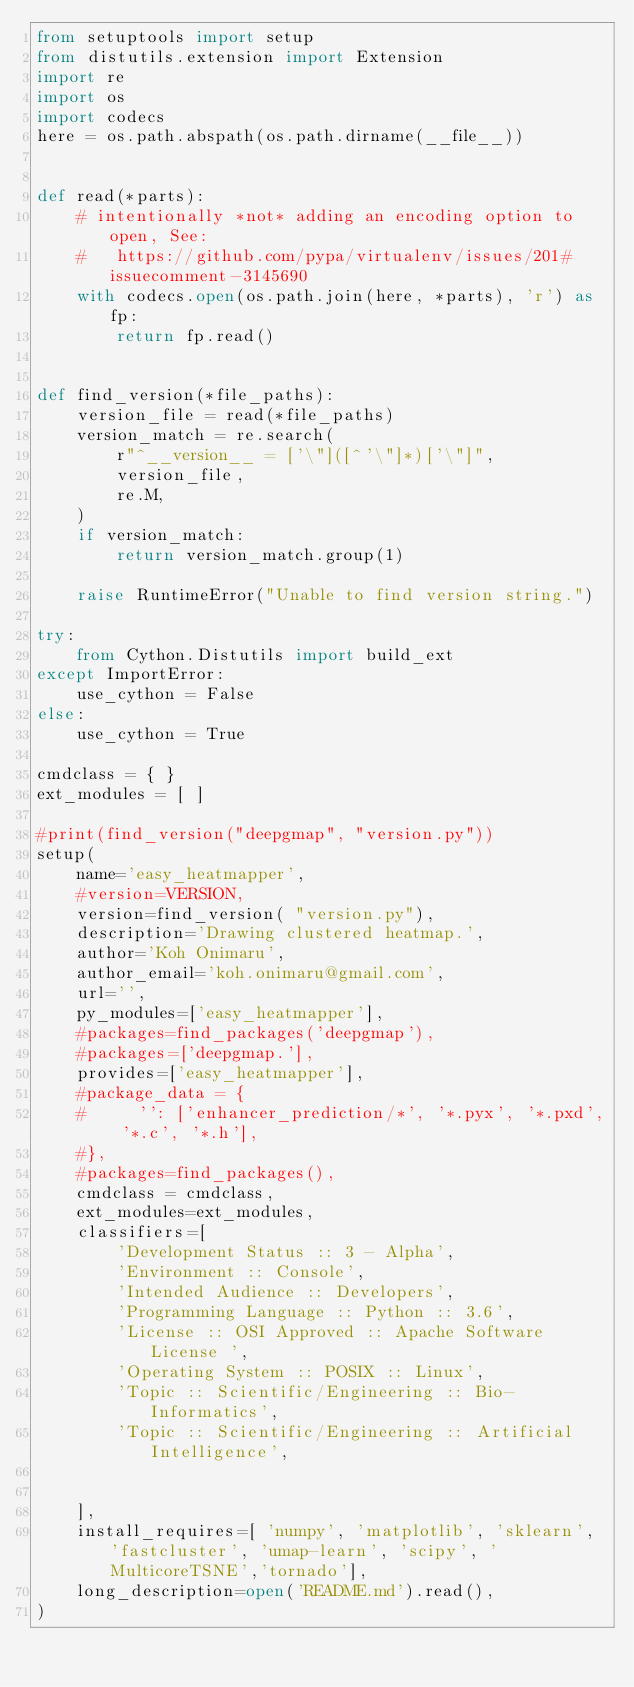Convert code to text. <code><loc_0><loc_0><loc_500><loc_500><_Python_>from setuptools import setup
from distutils.extension import Extension
import re
import os
import codecs
here = os.path.abspath(os.path.dirname(__file__))


def read(*parts):
    # intentionally *not* adding an encoding option to open, See:
    #   https://github.com/pypa/virtualenv/issues/201#issuecomment-3145690
    with codecs.open(os.path.join(here, *parts), 'r') as fp:
        return fp.read()


def find_version(*file_paths):
    version_file = read(*file_paths)
    version_match = re.search(
        r"^__version__ = ['\"]([^'\"]*)['\"]",
        version_file,
        re.M,
    )
    if version_match:
        return version_match.group(1)

    raise RuntimeError("Unable to find version string.")

try:
    from Cython.Distutils import build_ext
except ImportError:
    use_cython = False
else:
    use_cython = True

cmdclass = { }
ext_modules = [ ]

#print(find_version("deepgmap", "version.py"))
setup(
    name='easy_heatmapper',
    #version=VERSION,
    version=find_version( "version.py"),
    description='Drawing clustered heatmap.',
    author='Koh Onimaru',
    author_email='koh.onimaru@gmail.com',
    url='',
    py_modules=['easy_heatmapper'],
    #packages=find_packages('deepgmap'),
    #packages=['deepgmap.'],
    provides=['easy_heatmapper'],
    #package_data = {
    #     '': ['enhancer_prediction/*', '*.pyx', '*.pxd', '*.c', '*.h'],
    #},
    #packages=find_packages(),
    cmdclass = cmdclass,
    ext_modules=ext_modules,
    classifiers=[
        'Development Status :: 3 - Alpha',
        'Environment :: Console',
        'Intended Audience :: Developers',
        'Programming Language :: Python :: 3.6',
        'License :: OSI Approved :: Apache Software License ',
        'Operating System :: POSIX :: Linux',
        'Topic :: Scientific/Engineering :: Bio-Informatics',
        'Topic :: Scientific/Engineering :: Artificial Intelligence',
        
    
    ],
    install_requires=[ 'numpy', 'matplotlib', 'sklearn', 'fastcluster', 'umap-learn', 'scipy', 'MulticoreTSNE','tornado'],
    long_description=open('README.md').read(),
)</code> 